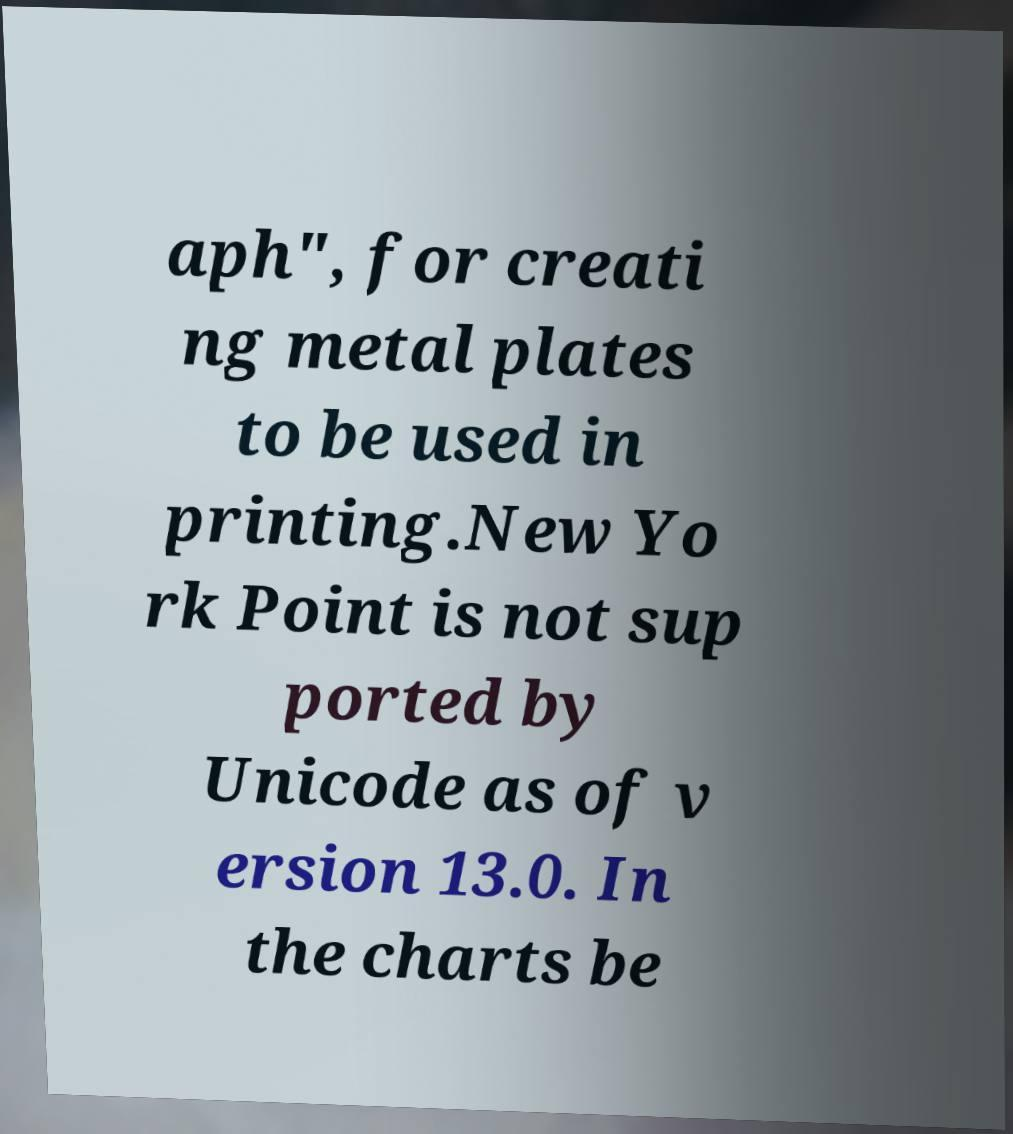For documentation purposes, I need the text within this image transcribed. Could you provide that? aph", for creati ng metal plates to be used in printing.New Yo rk Point is not sup ported by Unicode as of v ersion 13.0. In the charts be 